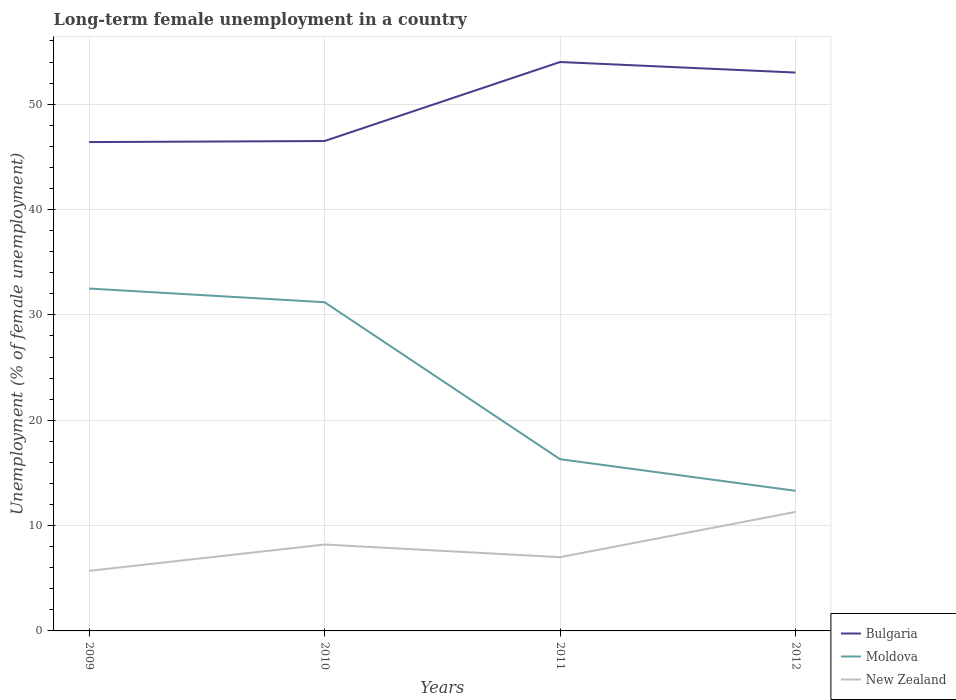How many different coloured lines are there?
Ensure brevity in your answer.  3. Does the line corresponding to Moldova intersect with the line corresponding to Bulgaria?
Provide a succinct answer. No. Across all years, what is the maximum percentage of long-term unemployed female population in Bulgaria?
Ensure brevity in your answer.  46.4. What is the total percentage of long-term unemployed female population in Bulgaria in the graph?
Keep it short and to the point. -6.5. What is the difference between the highest and the second highest percentage of long-term unemployed female population in New Zealand?
Your response must be concise. 5.6. What is the difference between the highest and the lowest percentage of long-term unemployed female population in Moldova?
Offer a terse response. 2. Is the percentage of long-term unemployed female population in Bulgaria strictly greater than the percentage of long-term unemployed female population in Moldova over the years?
Your answer should be compact. No. How many years are there in the graph?
Offer a terse response. 4. What is the difference between two consecutive major ticks on the Y-axis?
Give a very brief answer. 10. Does the graph contain any zero values?
Provide a succinct answer. No. Does the graph contain grids?
Offer a very short reply. Yes. How are the legend labels stacked?
Make the answer very short. Vertical. What is the title of the graph?
Offer a very short reply. Long-term female unemployment in a country. Does "Bhutan" appear as one of the legend labels in the graph?
Offer a very short reply. No. What is the label or title of the Y-axis?
Offer a terse response. Unemployment (% of female unemployment). What is the Unemployment (% of female unemployment) of Bulgaria in 2009?
Provide a short and direct response. 46.4. What is the Unemployment (% of female unemployment) of Moldova in 2009?
Make the answer very short. 32.5. What is the Unemployment (% of female unemployment) in New Zealand in 2009?
Your answer should be compact. 5.7. What is the Unemployment (% of female unemployment) of Bulgaria in 2010?
Ensure brevity in your answer.  46.5. What is the Unemployment (% of female unemployment) of Moldova in 2010?
Offer a terse response. 31.2. What is the Unemployment (% of female unemployment) in New Zealand in 2010?
Offer a very short reply. 8.2. What is the Unemployment (% of female unemployment) in Moldova in 2011?
Provide a succinct answer. 16.3. What is the Unemployment (% of female unemployment) of New Zealand in 2011?
Make the answer very short. 7. What is the Unemployment (% of female unemployment) of Moldova in 2012?
Give a very brief answer. 13.3. What is the Unemployment (% of female unemployment) in New Zealand in 2012?
Offer a terse response. 11.3. Across all years, what is the maximum Unemployment (% of female unemployment) of Bulgaria?
Your response must be concise. 54. Across all years, what is the maximum Unemployment (% of female unemployment) of Moldova?
Provide a succinct answer. 32.5. Across all years, what is the maximum Unemployment (% of female unemployment) in New Zealand?
Offer a very short reply. 11.3. Across all years, what is the minimum Unemployment (% of female unemployment) in Bulgaria?
Ensure brevity in your answer.  46.4. Across all years, what is the minimum Unemployment (% of female unemployment) in Moldova?
Make the answer very short. 13.3. Across all years, what is the minimum Unemployment (% of female unemployment) of New Zealand?
Your answer should be very brief. 5.7. What is the total Unemployment (% of female unemployment) of Bulgaria in the graph?
Provide a short and direct response. 199.9. What is the total Unemployment (% of female unemployment) of Moldova in the graph?
Your response must be concise. 93.3. What is the total Unemployment (% of female unemployment) of New Zealand in the graph?
Your answer should be compact. 32.2. What is the difference between the Unemployment (% of female unemployment) in New Zealand in 2009 and that in 2010?
Ensure brevity in your answer.  -2.5. What is the difference between the Unemployment (% of female unemployment) of Bulgaria in 2009 and that in 2011?
Keep it short and to the point. -7.6. What is the difference between the Unemployment (% of female unemployment) in New Zealand in 2009 and that in 2012?
Offer a very short reply. -5.6. What is the difference between the Unemployment (% of female unemployment) in Bulgaria in 2010 and that in 2011?
Ensure brevity in your answer.  -7.5. What is the difference between the Unemployment (% of female unemployment) in New Zealand in 2010 and that in 2012?
Make the answer very short. -3.1. What is the difference between the Unemployment (% of female unemployment) in Bulgaria in 2011 and that in 2012?
Provide a short and direct response. 1. What is the difference between the Unemployment (% of female unemployment) of Bulgaria in 2009 and the Unemployment (% of female unemployment) of New Zealand in 2010?
Provide a succinct answer. 38.2. What is the difference between the Unemployment (% of female unemployment) in Moldova in 2009 and the Unemployment (% of female unemployment) in New Zealand in 2010?
Give a very brief answer. 24.3. What is the difference between the Unemployment (% of female unemployment) of Bulgaria in 2009 and the Unemployment (% of female unemployment) of Moldova in 2011?
Make the answer very short. 30.1. What is the difference between the Unemployment (% of female unemployment) of Bulgaria in 2009 and the Unemployment (% of female unemployment) of New Zealand in 2011?
Keep it short and to the point. 39.4. What is the difference between the Unemployment (% of female unemployment) of Bulgaria in 2009 and the Unemployment (% of female unemployment) of Moldova in 2012?
Offer a terse response. 33.1. What is the difference between the Unemployment (% of female unemployment) in Bulgaria in 2009 and the Unemployment (% of female unemployment) in New Zealand in 2012?
Your response must be concise. 35.1. What is the difference between the Unemployment (% of female unemployment) of Moldova in 2009 and the Unemployment (% of female unemployment) of New Zealand in 2012?
Make the answer very short. 21.2. What is the difference between the Unemployment (% of female unemployment) in Bulgaria in 2010 and the Unemployment (% of female unemployment) in Moldova in 2011?
Your answer should be very brief. 30.2. What is the difference between the Unemployment (% of female unemployment) in Bulgaria in 2010 and the Unemployment (% of female unemployment) in New Zealand in 2011?
Provide a succinct answer. 39.5. What is the difference between the Unemployment (% of female unemployment) of Moldova in 2010 and the Unemployment (% of female unemployment) of New Zealand in 2011?
Your response must be concise. 24.2. What is the difference between the Unemployment (% of female unemployment) in Bulgaria in 2010 and the Unemployment (% of female unemployment) in Moldova in 2012?
Provide a succinct answer. 33.2. What is the difference between the Unemployment (% of female unemployment) of Bulgaria in 2010 and the Unemployment (% of female unemployment) of New Zealand in 2012?
Provide a succinct answer. 35.2. What is the difference between the Unemployment (% of female unemployment) of Moldova in 2010 and the Unemployment (% of female unemployment) of New Zealand in 2012?
Provide a succinct answer. 19.9. What is the difference between the Unemployment (% of female unemployment) of Bulgaria in 2011 and the Unemployment (% of female unemployment) of Moldova in 2012?
Ensure brevity in your answer.  40.7. What is the difference between the Unemployment (% of female unemployment) in Bulgaria in 2011 and the Unemployment (% of female unemployment) in New Zealand in 2012?
Provide a succinct answer. 42.7. What is the difference between the Unemployment (% of female unemployment) of Moldova in 2011 and the Unemployment (% of female unemployment) of New Zealand in 2012?
Provide a succinct answer. 5. What is the average Unemployment (% of female unemployment) of Bulgaria per year?
Give a very brief answer. 49.98. What is the average Unemployment (% of female unemployment) of Moldova per year?
Make the answer very short. 23.32. What is the average Unemployment (% of female unemployment) of New Zealand per year?
Keep it short and to the point. 8.05. In the year 2009, what is the difference between the Unemployment (% of female unemployment) of Bulgaria and Unemployment (% of female unemployment) of Moldova?
Offer a terse response. 13.9. In the year 2009, what is the difference between the Unemployment (% of female unemployment) in Bulgaria and Unemployment (% of female unemployment) in New Zealand?
Make the answer very short. 40.7. In the year 2009, what is the difference between the Unemployment (% of female unemployment) of Moldova and Unemployment (% of female unemployment) of New Zealand?
Provide a short and direct response. 26.8. In the year 2010, what is the difference between the Unemployment (% of female unemployment) in Bulgaria and Unemployment (% of female unemployment) in Moldova?
Provide a short and direct response. 15.3. In the year 2010, what is the difference between the Unemployment (% of female unemployment) in Bulgaria and Unemployment (% of female unemployment) in New Zealand?
Provide a succinct answer. 38.3. In the year 2011, what is the difference between the Unemployment (% of female unemployment) of Bulgaria and Unemployment (% of female unemployment) of Moldova?
Provide a succinct answer. 37.7. In the year 2011, what is the difference between the Unemployment (% of female unemployment) in Bulgaria and Unemployment (% of female unemployment) in New Zealand?
Make the answer very short. 47. In the year 2011, what is the difference between the Unemployment (% of female unemployment) in Moldova and Unemployment (% of female unemployment) in New Zealand?
Your answer should be compact. 9.3. In the year 2012, what is the difference between the Unemployment (% of female unemployment) of Bulgaria and Unemployment (% of female unemployment) of Moldova?
Offer a very short reply. 39.7. In the year 2012, what is the difference between the Unemployment (% of female unemployment) of Bulgaria and Unemployment (% of female unemployment) of New Zealand?
Your answer should be very brief. 41.7. In the year 2012, what is the difference between the Unemployment (% of female unemployment) of Moldova and Unemployment (% of female unemployment) of New Zealand?
Make the answer very short. 2. What is the ratio of the Unemployment (% of female unemployment) in Moldova in 2009 to that in 2010?
Keep it short and to the point. 1.04. What is the ratio of the Unemployment (% of female unemployment) in New Zealand in 2009 to that in 2010?
Your answer should be very brief. 0.7. What is the ratio of the Unemployment (% of female unemployment) in Bulgaria in 2009 to that in 2011?
Your answer should be compact. 0.86. What is the ratio of the Unemployment (% of female unemployment) in Moldova in 2009 to that in 2011?
Offer a terse response. 1.99. What is the ratio of the Unemployment (% of female unemployment) of New Zealand in 2009 to that in 2011?
Offer a very short reply. 0.81. What is the ratio of the Unemployment (% of female unemployment) in Bulgaria in 2009 to that in 2012?
Ensure brevity in your answer.  0.88. What is the ratio of the Unemployment (% of female unemployment) in Moldova in 2009 to that in 2012?
Your answer should be compact. 2.44. What is the ratio of the Unemployment (% of female unemployment) in New Zealand in 2009 to that in 2012?
Provide a short and direct response. 0.5. What is the ratio of the Unemployment (% of female unemployment) in Bulgaria in 2010 to that in 2011?
Your answer should be very brief. 0.86. What is the ratio of the Unemployment (% of female unemployment) of Moldova in 2010 to that in 2011?
Provide a succinct answer. 1.91. What is the ratio of the Unemployment (% of female unemployment) of New Zealand in 2010 to that in 2011?
Give a very brief answer. 1.17. What is the ratio of the Unemployment (% of female unemployment) in Bulgaria in 2010 to that in 2012?
Your answer should be very brief. 0.88. What is the ratio of the Unemployment (% of female unemployment) of Moldova in 2010 to that in 2012?
Offer a terse response. 2.35. What is the ratio of the Unemployment (% of female unemployment) in New Zealand in 2010 to that in 2012?
Your response must be concise. 0.73. What is the ratio of the Unemployment (% of female unemployment) of Bulgaria in 2011 to that in 2012?
Your answer should be compact. 1.02. What is the ratio of the Unemployment (% of female unemployment) in Moldova in 2011 to that in 2012?
Offer a very short reply. 1.23. What is the ratio of the Unemployment (% of female unemployment) in New Zealand in 2011 to that in 2012?
Ensure brevity in your answer.  0.62. What is the difference between the highest and the second highest Unemployment (% of female unemployment) of Bulgaria?
Offer a terse response. 1. What is the difference between the highest and the second highest Unemployment (% of female unemployment) of Moldova?
Your response must be concise. 1.3. 